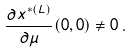Convert formula to latex. <formula><loc_0><loc_0><loc_500><loc_500>\frac { \partial x ^ { * ( L ) } } { \partial \mu } ( 0 , 0 ) \ne 0 \, .</formula> 